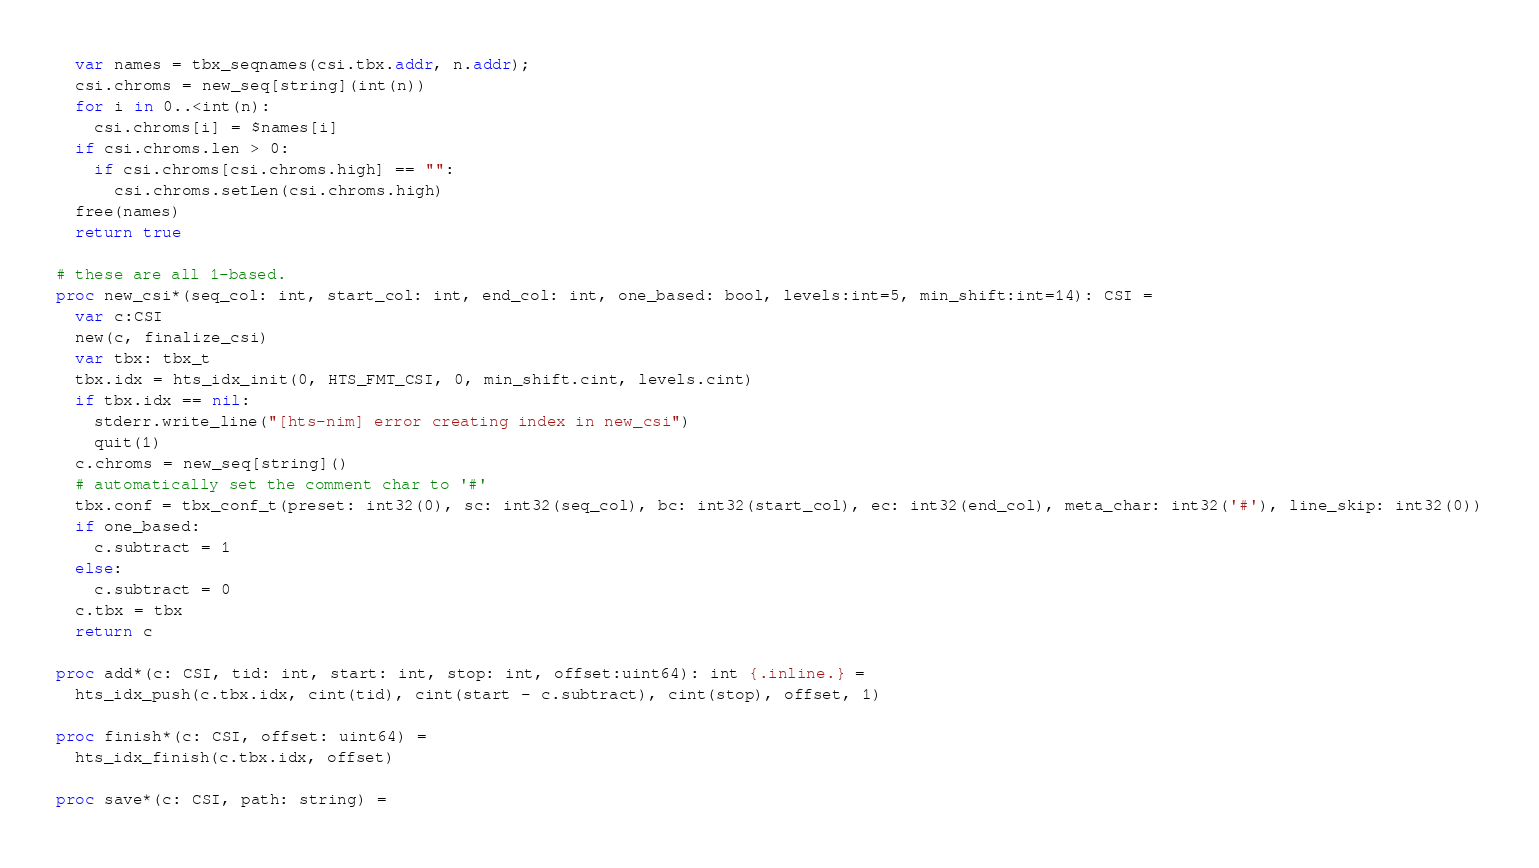Convert code to text. <code><loc_0><loc_0><loc_500><loc_500><_Nim_>  var names = tbx_seqnames(csi.tbx.addr, n.addr);
  csi.chroms = new_seq[string](int(n))
  for i in 0..<int(n):
    csi.chroms[i] = $names[i]
  if csi.chroms.len > 0:
    if csi.chroms[csi.chroms.high] == "":
      csi.chroms.setLen(csi.chroms.high)
  free(names)
  return true

# these are all 1-based.
proc new_csi*(seq_col: int, start_col: int, end_col: int, one_based: bool, levels:int=5, min_shift:int=14): CSI =
  var c:CSI
  new(c, finalize_csi)
  var tbx: tbx_t
  tbx.idx = hts_idx_init(0, HTS_FMT_CSI, 0, min_shift.cint, levels.cint)
  if tbx.idx == nil:
    stderr.write_line("[hts-nim] error creating index in new_csi")
    quit(1)
  c.chroms = new_seq[string]()
  # automatically set the comment char to '#'
  tbx.conf = tbx_conf_t(preset: int32(0), sc: int32(seq_col), bc: int32(start_col), ec: int32(end_col), meta_char: int32('#'), line_skip: int32(0))
  if one_based:
    c.subtract = 1
  else:
    c.subtract = 0
  c.tbx = tbx
  return c

proc add*(c: CSI, tid: int, start: int, stop: int, offset:uint64): int {.inline.} =
  hts_idx_push(c.tbx.idx, cint(tid), cint(start - c.subtract), cint(stop), offset, 1)

proc finish*(c: CSI, offset: uint64) =
  hts_idx_finish(c.tbx.idx, offset)

proc save*(c: CSI, path: string) =</code> 